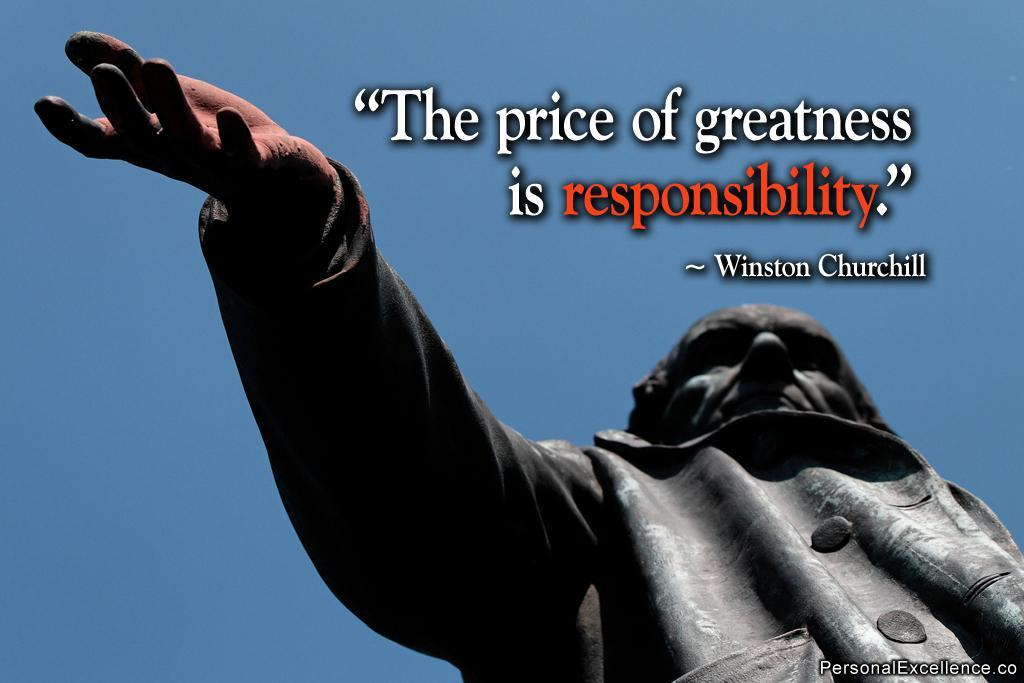Who or what is present in the image? There is a person in the image. What can be observed about the person's attire? The person is wearing clothes. What else is visible in the image besides the person? There is text in the image. What is the color of the sky in the image? The sky is blue in the image. Is there any additional mark or feature in the image? Yes, there is a watermark in the bottom right corner of the image. What type of brick pattern can be seen on the person's shirt in the image? There is no brick pattern visible on the person's shirt in the image. How many waves are crashing against the shore in the image? There is no shore or waves present in the image. 